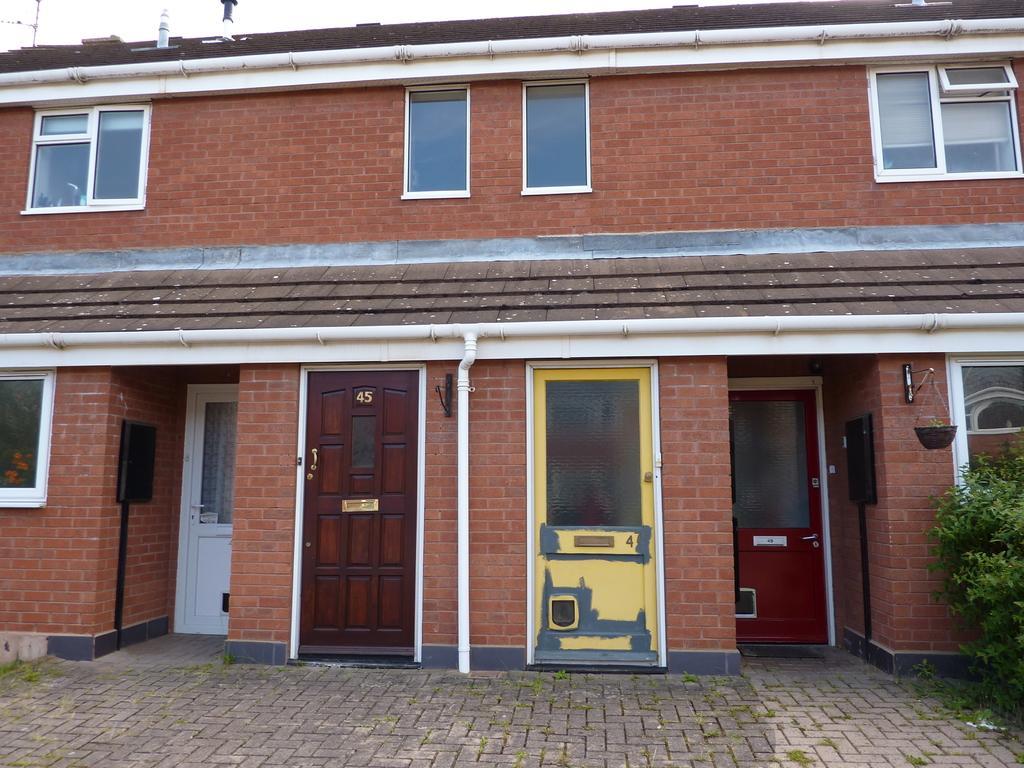How would you summarize this image in a sentence or two? In this image I can see the ground, a tree which is green in color and a building which is brown and white in color. I can see few windows and few doors which are white, brown, yellow and red in color. In the background I can see the sky. 